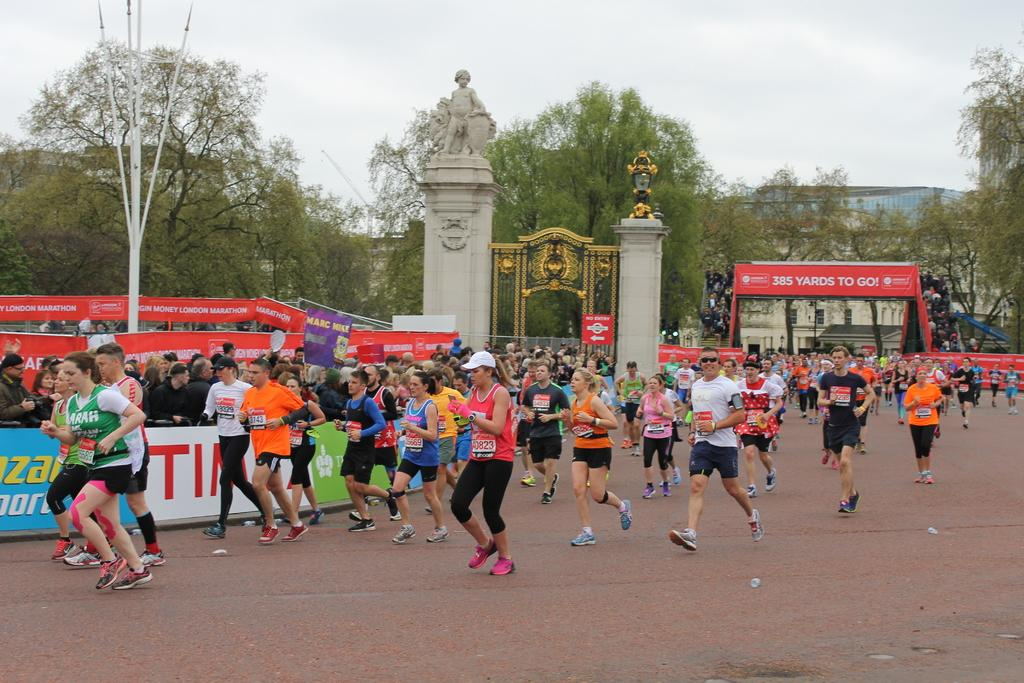How many people can be seen in the image? There are people in the image, but the exact number is not specified. What are some of the people doing in the image? Some people are standing in the image. What can be seen under the people's feet? The ground is visible in the image. What type of structures are present in the image? There are poles, a statue, a building, and a gate in the image. What else can be seen in the background of the image? Trees and posters are visible in the image. What is visible above the structures and people in the image? The sky is visible in the image. What type of food is being sold in the store in the image? There is no store present in the image, so it is not possible to determine what type of food might be sold there. 